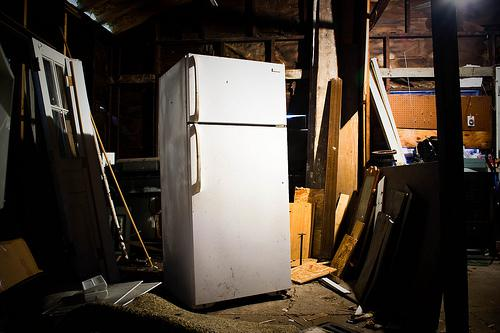Question: who is there?
Choices:
A. One man.
B. No one.
C. One young woman.
D. One elderly woman.
Answer with the letter. Answer: B Question: what is there?
Choices:
A. Dish washer.
B. Fridge.
C. Table.
D. Counter.
Answer with the letter. Answer: B 